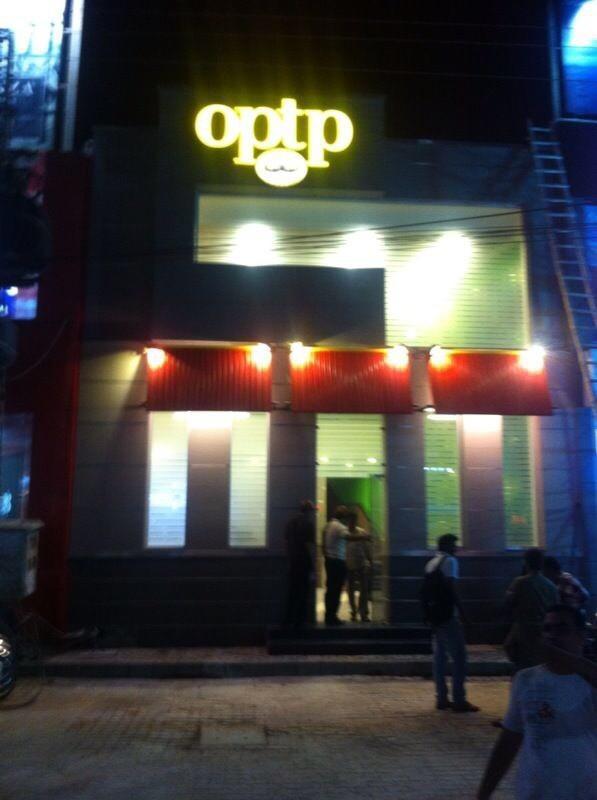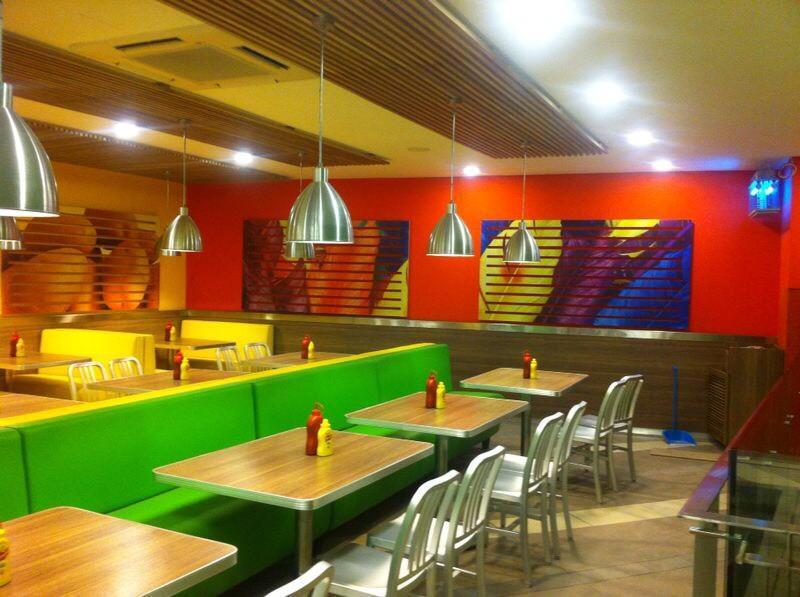The first image is the image on the left, the second image is the image on the right. For the images shown, is this caption "There are at least three cars in one image." true? Answer yes or no. No. The first image is the image on the left, the second image is the image on the right. Analyze the images presented: Is the assertion "There are people in both images." valid? Answer yes or no. No. 